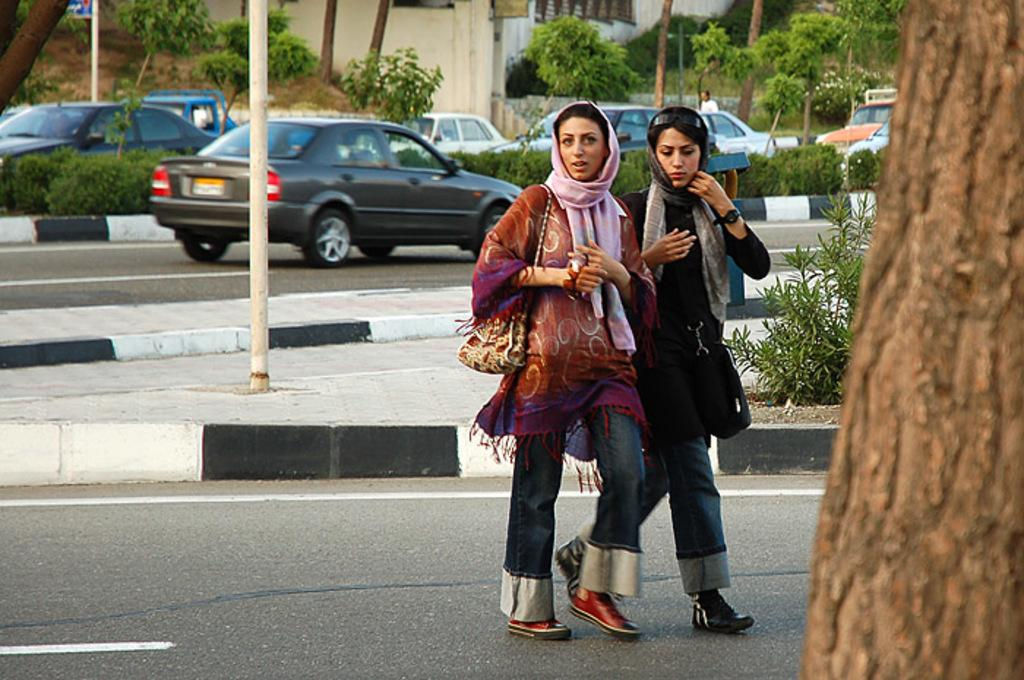How many people are present in the image? There are two persons standing in the image. What can be seen in the background of the image? There are trees and cars in the background of the image. What type of cloud is present in the image? There is no cloud present in the image; only trees and cars are visible in the background. 